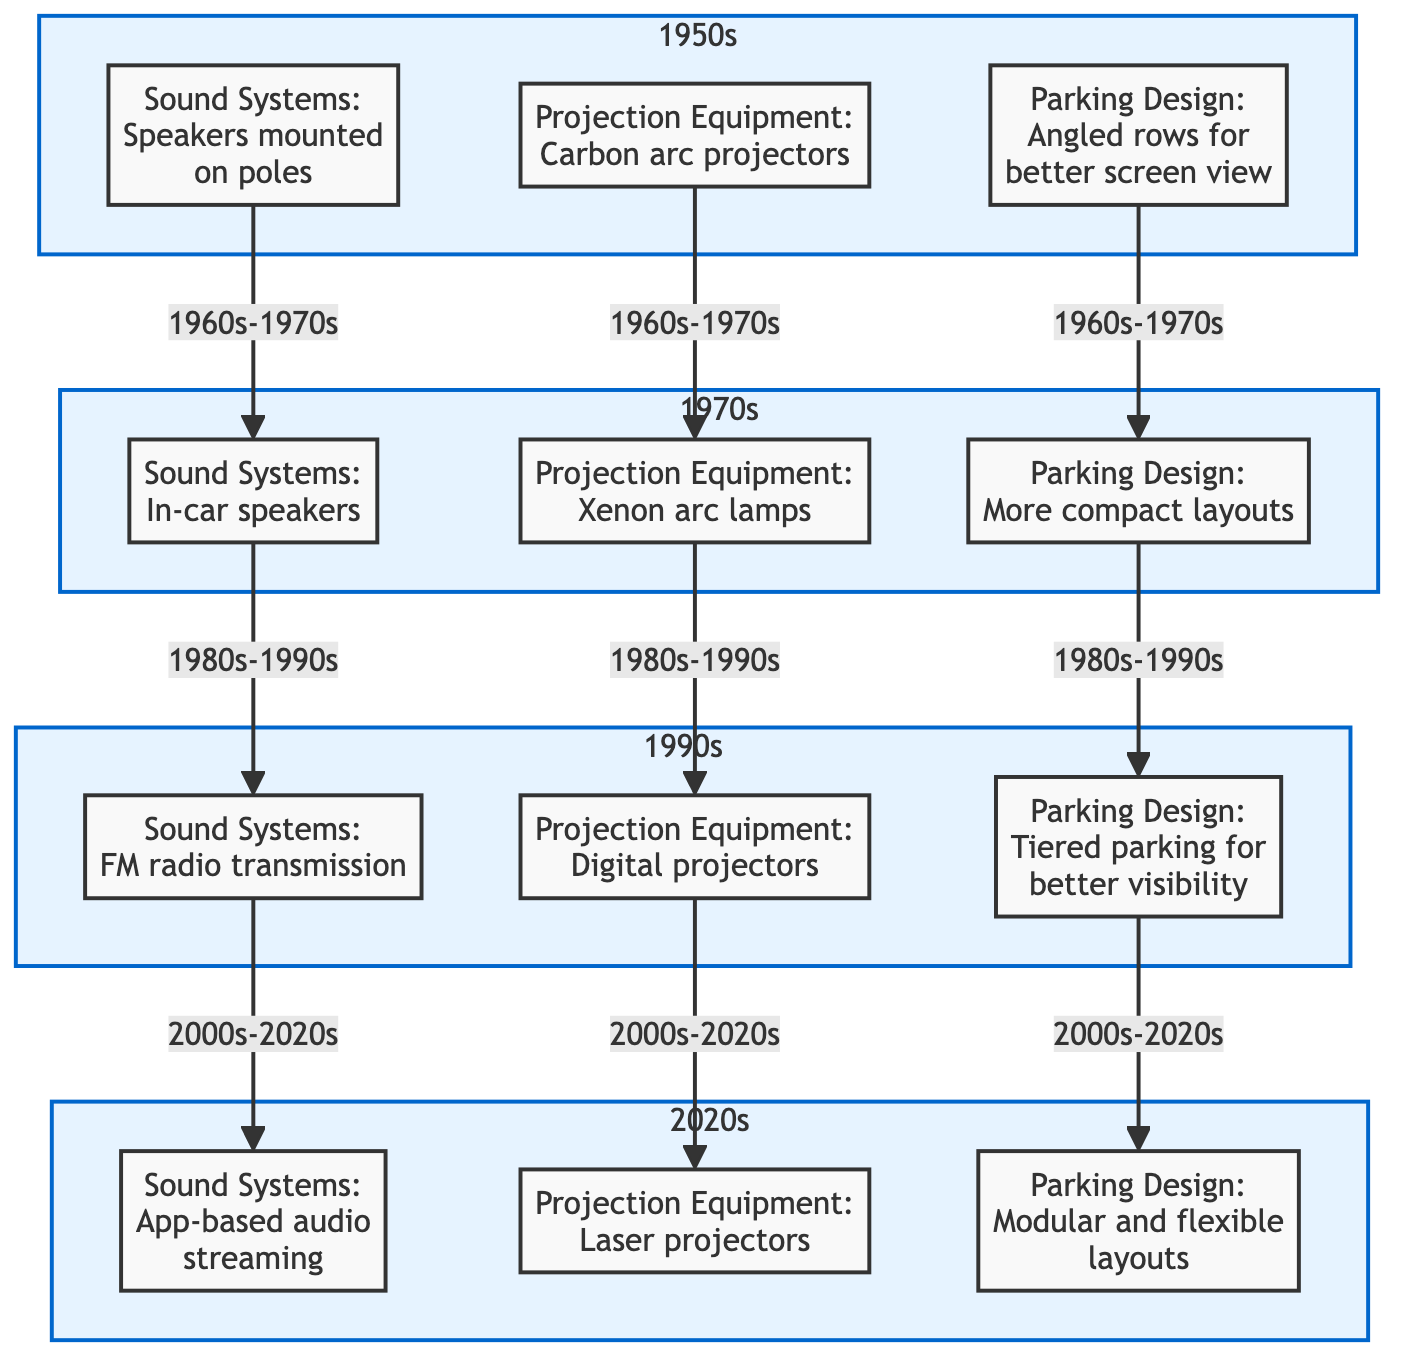What sound system was used in the 1950s? The diagram clearly states that the sound system used in the 1950s was "Speakers mounted on poles." This node is directly under the 1950s subgraph without any further connections needed to find the answer.
Answer: Speakers mounted on poles What projection equipment was introduced in the 1970s? According to the diagram, the projection equipment in the 1970s is labeled as "Xenon arc lamps." This information is found in the 1970s subgraph, indicating the technology used during that decade.
Answer: Xenon arc lamps Which decade featured in-car speakers? The diagram indicates that in-car speakers were introduced in the 1970s, as shown in the corresponding node under the 1970s subgraph. The answer is found by directly referencing this specific node in the diagram.
Answer: 1970s What advancement in parking design was made in the 1990s? The parking design advancement in the 1990s is described as "Tiered parking for better visibility." This information is found in the 1990s subgraph, making it straightforward to locate the relevant node.
Answer: Tiered parking for better visibility Which decades experienced a transition in projection equipment from carbon arc projectors to digital projectors? To answer this, we track the flow of projection equipment. From the 1950s (carbon arc projectors) to the 1970s (Xenon arc lamps) and finally to the 1990s (digital projectors), this change occurs over three decades. Thus, the transition spans from the 1950s through the 1990s, as reflected in the diagram.
Answer: 1950s to 1990s How many types of parking design advancements are shown in the diagram? The diagram presents three types of parking design advancements; one from each decade: the 1950s, 1970s, 1990s, and 2020s. By simply counting the nodes related to parking design, we arrive at the answer of four.
Answer: Four What is the latest sound system technology depicted in the diagram? The diagram's 2020s subgraph states that the latest sound system technology is "App-based audio streaming." This node reflects the most current advancement in sound systems based on the timeline presented in the diagram.
Answer: App-based audio streaming Which nodes are connected directly to the 1990s projection equipment node? The only direct connection to the 1990s projection equipment node ("Digital projectors") is from the 1970s projection equipment node ("Xenon arc lamps"). Therefore, the nodes that are directly linked to it are from the previous decade, 1970s.
Answer: 1970s projection equipment 